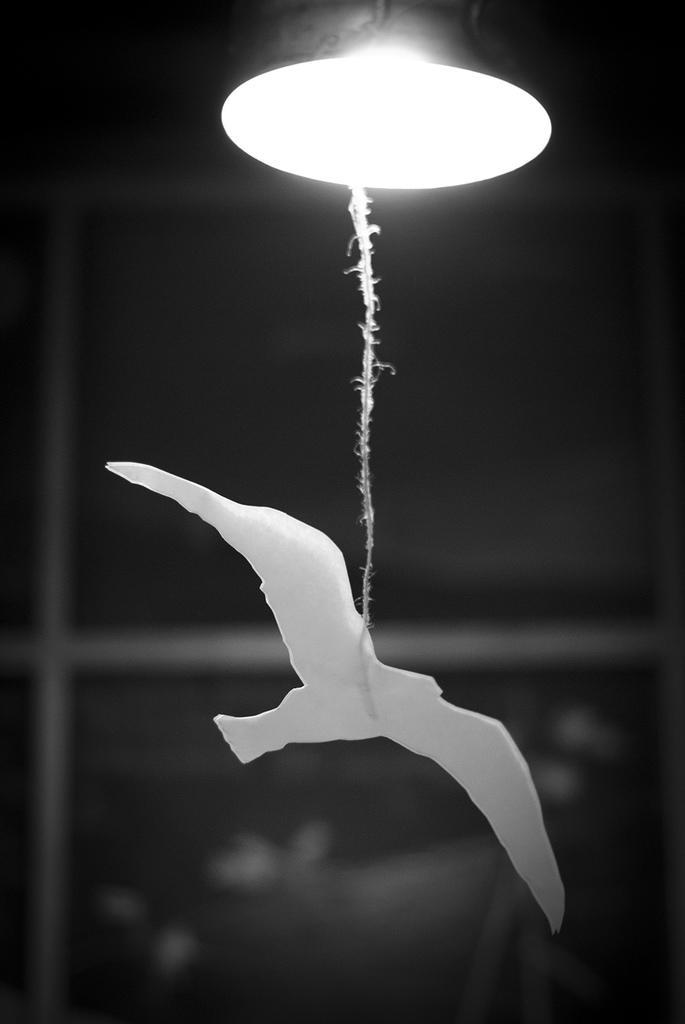How would you summarize this image in a sentence or two? In this image I can see a lamp. I can see a bird structure attached to the rope and rope is attached to the lamp. Background is in black color. 